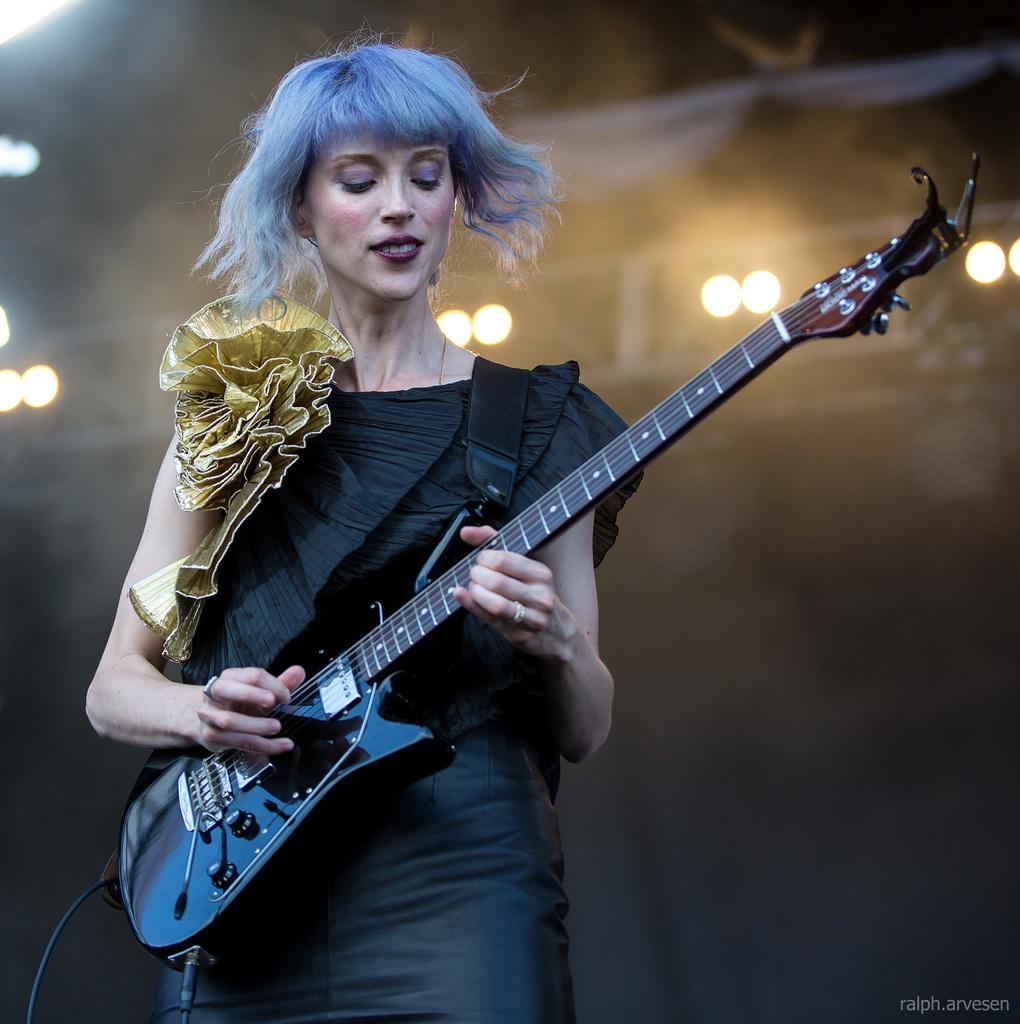Who is the main subject in the image? There is a woman in the image. What is the woman doing in the image? The woman is standing and holding a guitar in her hands. What can be seen in the background of the image? There are lights visible in the background. What type of instrument is the woman's father playing in the image? There is no mention of the woman's father or any other instruments in the image. 